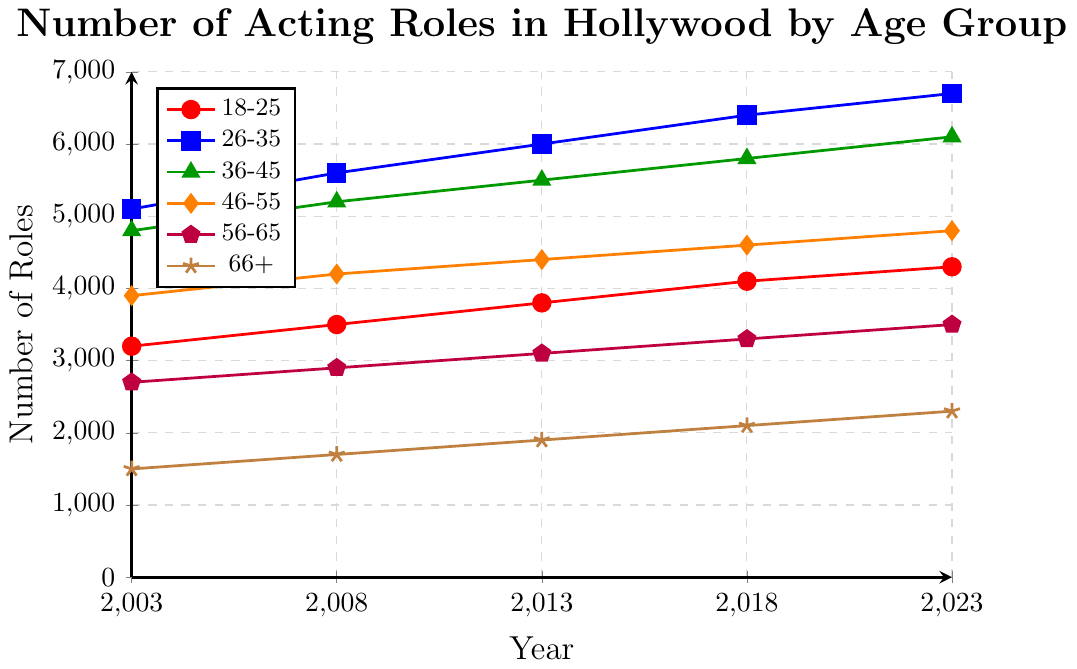what is the age group with the highest number of roles in 2023? Looking at the labels on the y-axis and the points plotted for the year 2023, the blue line representing the age group 26-35 is the highest.
Answer: 26-35 How many more acting roles were available for the 36-45 age group in 2018 compared to 2003? In 2003, the number of roles for the 36-45 age group was 4800 and in 2018 it was 5800. The difference is 5800 - 4800 = 1000.
Answer: 1000 What is the trend in the number of roles for the 46-55 age group from 2003 to 2023? Observe the orange line representing the 46-55 age group, noting that the number steadily increases from 3900 in 2003 to 4800 in 2023.
Answer: Increasing Which age group had the least increase in available roles from 2003 to 2023? Calculate the differences over the years: 18-25: 4300-3200 = 1100, 26-35: 6700-5100 = 1600, 36-45: 6100-4800 = 1300, 46-55: 4800-3900 = 900, 56-65: 3500-2700 = 800, 66+: 2300-1500 = 800. The least increase is for the 56-65 and 66+ age groups, both with an increase of 800 roles.
Answer: 56-65 and 66+ What is the average number of roles available for the 18-25 age group over the 20-year span? Sum the values (3200 + 3500 + 3800 + 4100 + 4300) = 18900, and divide by the number of years with data points, which is 5. 18900 / 5 = 3780.
Answer: 3780 How did the number of roles for the 26-35 age group compare to the 36-45 age group in 2008? In 2008, the number of roles for 26-35 was 5600 and for 36-45 it was 5200. Since 5600 > 5200, the 26-35 age group had more roles.
Answer: 26-35 > 36-45 Which age group shows the most consistent increase in roles over the 20 years? The lines for the age groups 26-35, 46-55, and 56-65 all show consistent increases, but the 26-35 age group (blue line) has the most significant and steady increase.
Answer: 26-35 What is the average annual growth rate for the 66+ age group from 2003 to 2023? The change in roles is 2300 - 1500 = 800 over 20 years. The average annual growth rate is 800 / 20 = 40 roles per year.
Answer: 40 